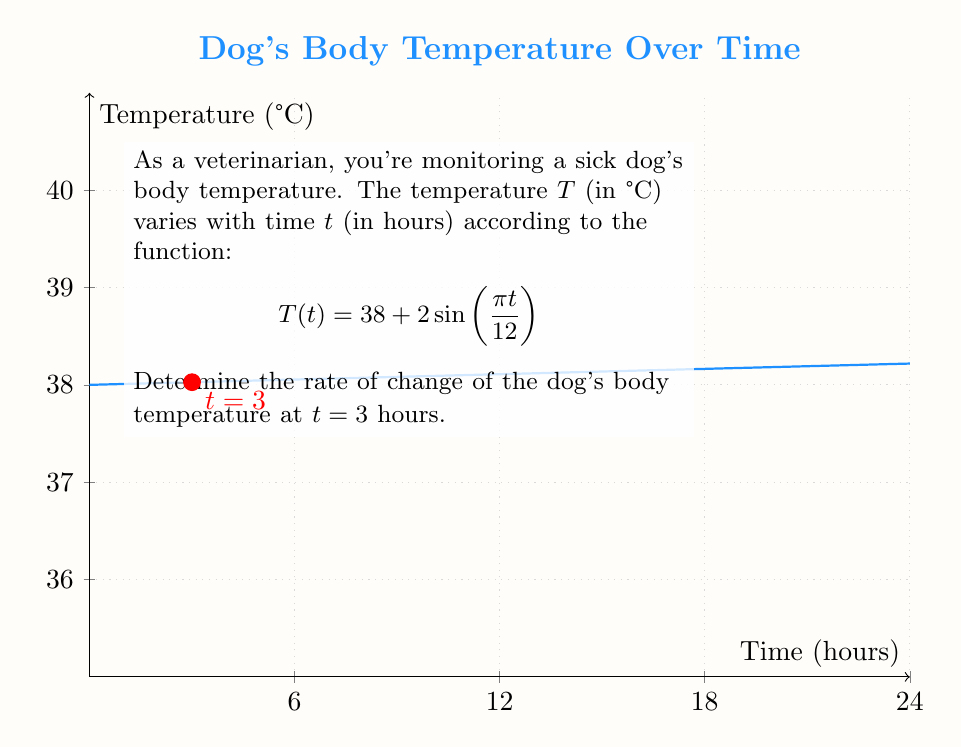Can you answer this question? To find the rate of change of the dog's body temperature at $t = 3$ hours, we need to calculate the derivative of $T(t)$ and evaluate it at $t = 3$.

Step 1: Find the derivative of $T(t)$.
$$T(t) = 38 + 2\sin(\frac{\pi t}{12})$$
Using the chain rule, we get:
$$T'(t) = 2 \cdot \cos(\frac{\pi t}{12}) \cdot \frac{\pi}{12}$$
$$T'(t) = \frac{\pi}{6} \cos(\frac{\pi t}{12})$$

Step 2: Evaluate $T'(t)$ at $t = 3$.
$$T'(3) = \frac{\pi}{6} \cos(\frac{\pi \cdot 3}{12})$$
$$T'(3) = \frac{\pi}{6} \cos(\frac{\pi}{4})$$

Step 3: Simplify the expression.
We know that $\cos(\frac{\pi}{4}) = \frac{\sqrt{2}}{2}$, so:
$$T'(3) = \frac{\pi}{6} \cdot \frac{\sqrt{2}}{2}$$
$$T'(3) = \frac{\pi\sqrt{2}}{12}$$

This value represents the instantaneous rate of change of the dog's body temperature at $t = 3$ hours, measured in °C per hour.
Answer: $\frac{\pi\sqrt{2}}{12}$ °C/hour 